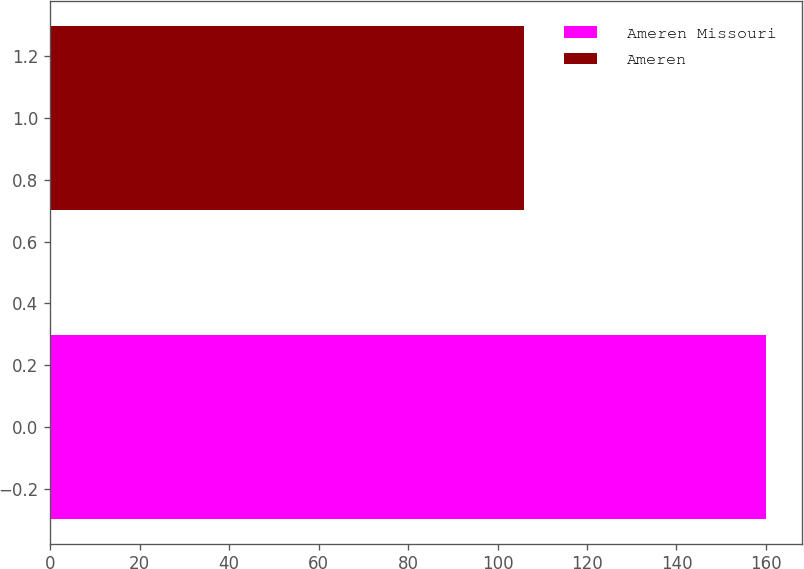Convert chart. <chart><loc_0><loc_0><loc_500><loc_500><bar_chart><fcel>Ameren Missouri<fcel>Ameren<nl><fcel>160<fcel>106<nl></chart> 